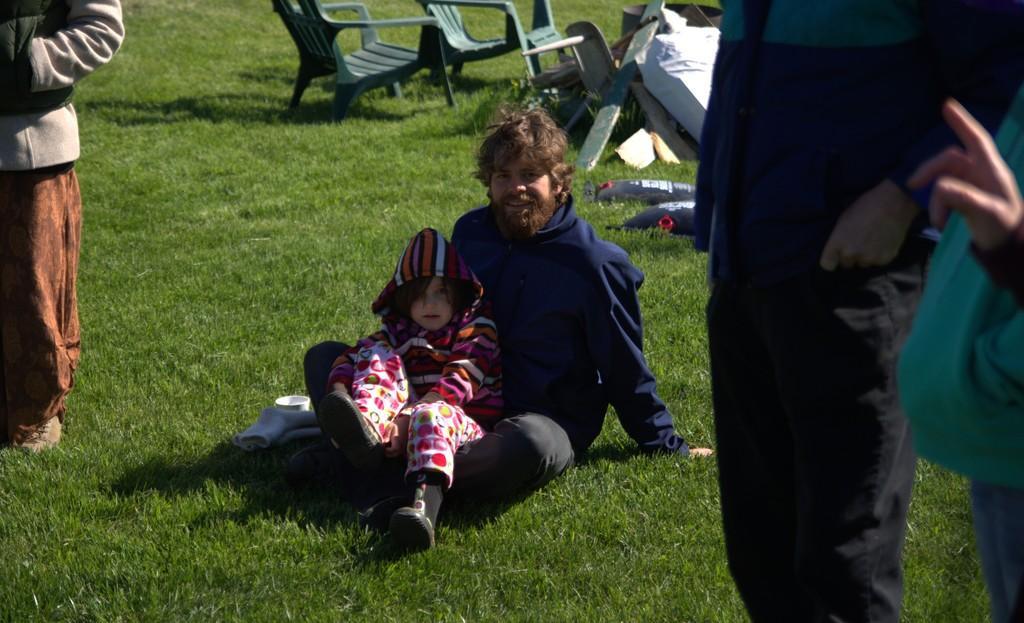Can you describe this image briefly? In this picture there are people and we can see chairs, grass and objects. 